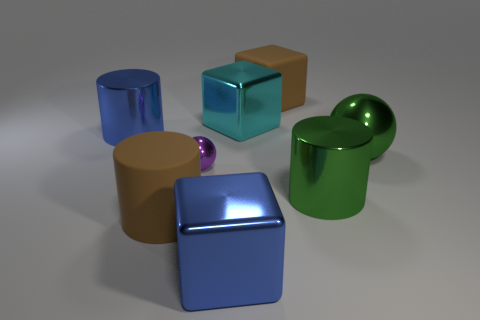Is there anything else of the same color as the large matte cube?
Your response must be concise. Yes. What material is the large brown object that is the same shape as the cyan metal thing?
Provide a short and direct response. Rubber. How many other things are there of the same size as the green metal cylinder?
Offer a very short reply. 6. What material is the tiny object?
Keep it short and to the point. Metal. Is the number of big metal objects that are to the right of the large brown matte cylinder greater than the number of small red things?
Provide a short and direct response. Yes. Are any large blue things visible?
Ensure brevity in your answer.  Yes. How many other things are there of the same shape as the purple thing?
Provide a succinct answer. 1. There is a sphere that is right of the green shiny cylinder; is it the same color as the metal cylinder that is in front of the green metal ball?
Your answer should be very brief. Yes. How big is the ball that is on the left side of the large blue thing in front of the large brown matte thing to the left of the brown block?
Provide a succinct answer. Small. The thing that is behind the brown cylinder and left of the purple shiny ball has what shape?
Offer a terse response. Cylinder. 